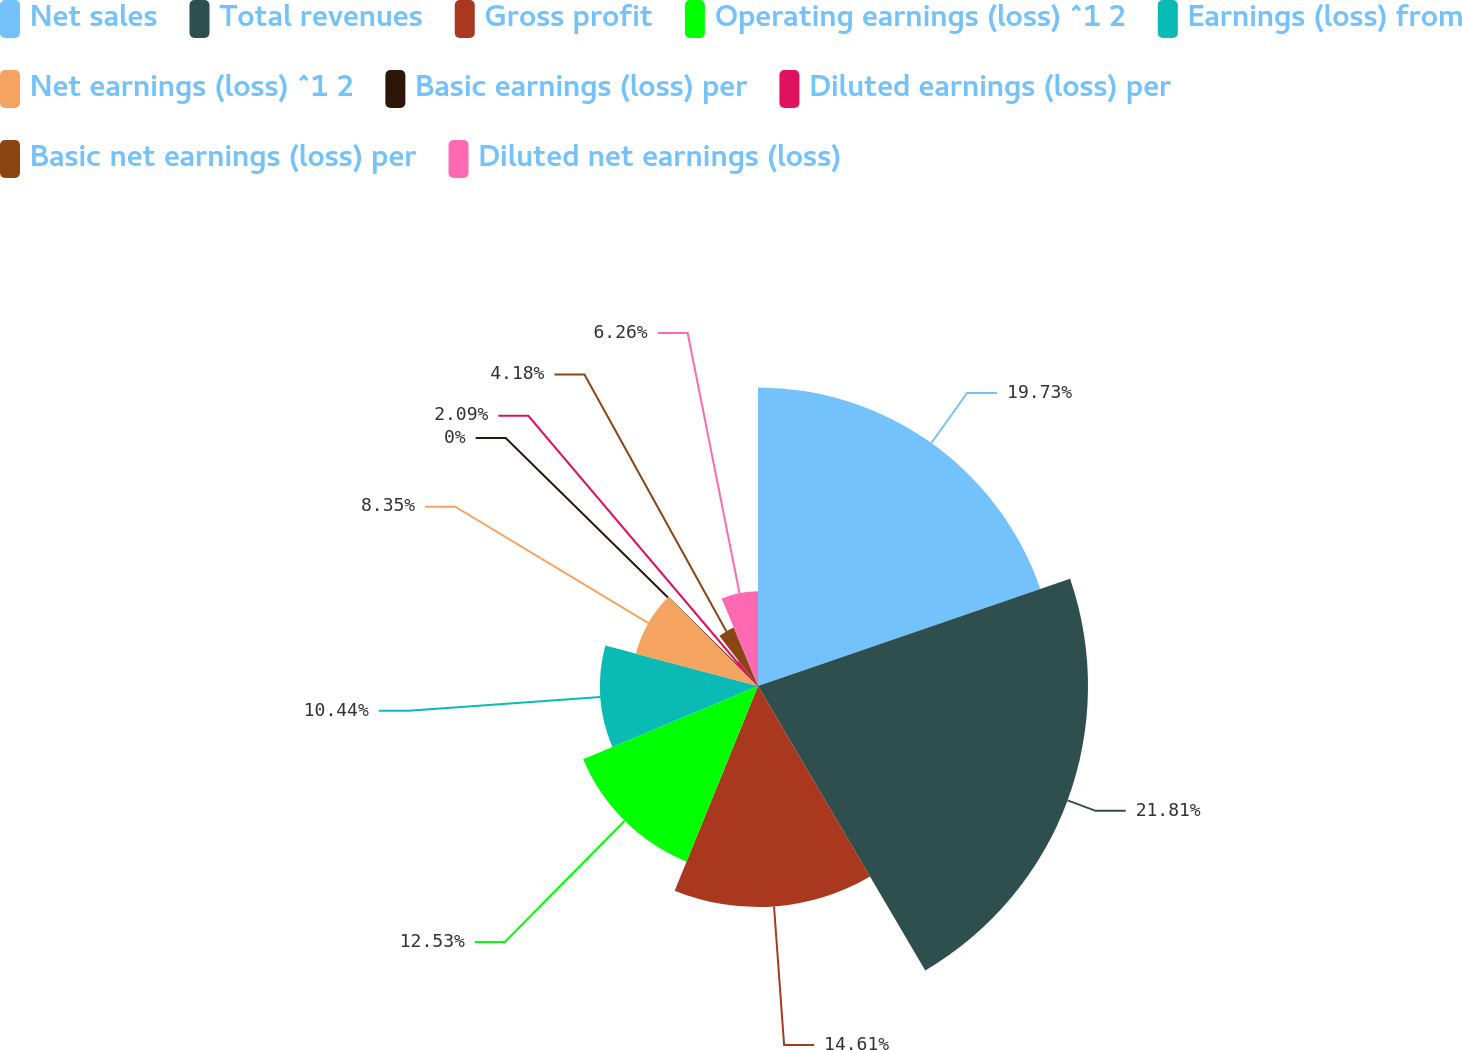Convert chart to OTSL. <chart><loc_0><loc_0><loc_500><loc_500><pie_chart><fcel>Net sales<fcel>Total revenues<fcel>Gross profit<fcel>Operating earnings (loss) ^1 2<fcel>Earnings (loss) from<fcel>Net earnings (loss) ^1 2<fcel>Basic earnings (loss) per<fcel>Diluted earnings (loss) per<fcel>Basic net earnings (loss) per<fcel>Diluted net earnings (loss)<nl><fcel>19.73%<fcel>21.81%<fcel>14.61%<fcel>12.53%<fcel>10.44%<fcel>8.35%<fcel>0.0%<fcel>2.09%<fcel>4.18%<fcel>6.26%<nl></chart> 